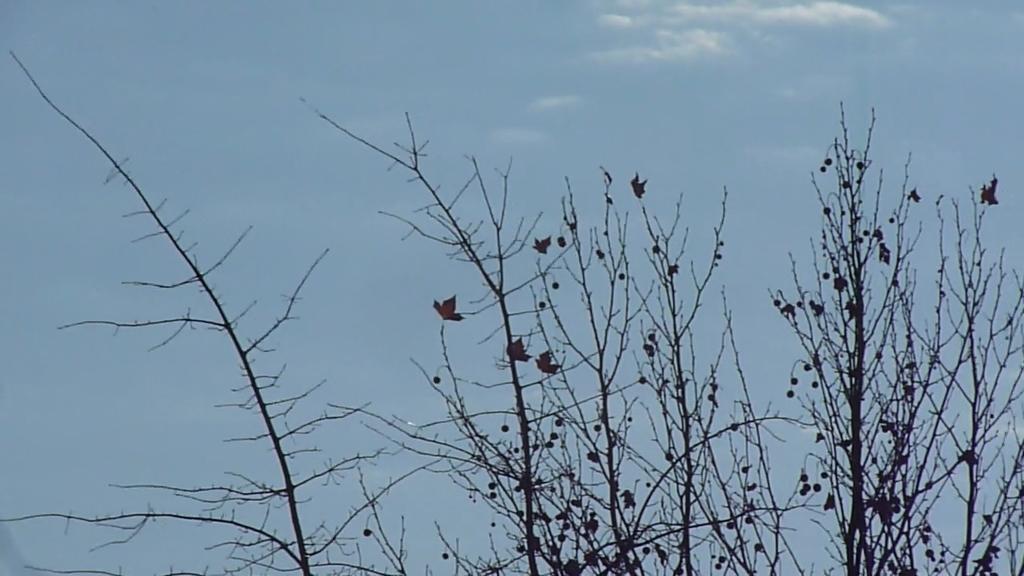In one or two sentences, can you explain what this image depicts? There is a dried tree which has few dried leaves and some other objects on it. 